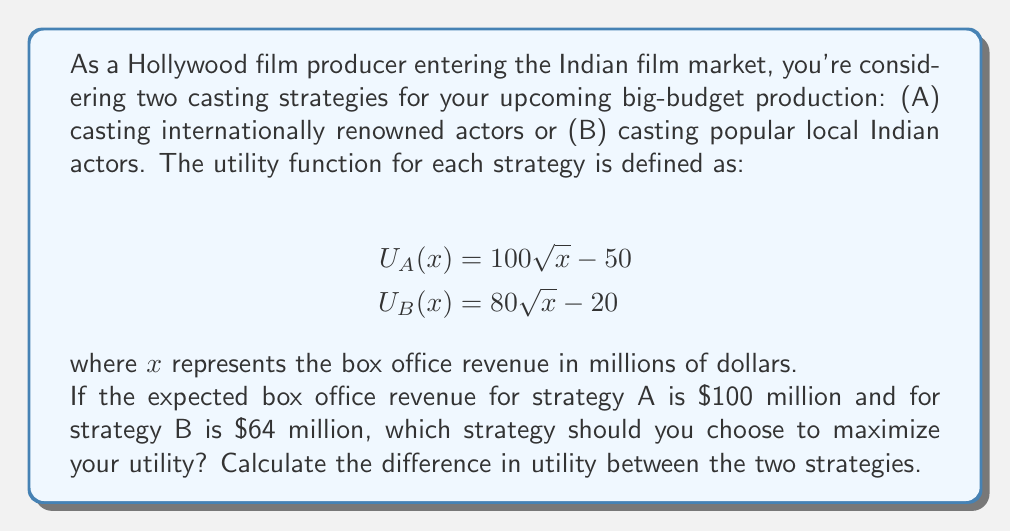Give your solution to this math problem. To solve this problem, we need to calculate the utility for each strategy using the given utility functions and expected box office revenues. Then, we'll compare the results to determine which strategy maximizes utility.

1. Calculate utility for Strategy A (International actors):
   $$U_A(100) = 100\sqrt{100} - 50$$
   $$U_A(100) = 100 \cdot 10 - 50 = 950$$

2. Calculate utility for Strategy B (Local Indian actors):
   $$U_B(64) = 80\sqrt{64} - 20$$
   $$U_B(64) = 80 \cdot 8 - 20 = 620$$

3. Compare the utilities:
   Strategy A yields a higher utility (950) compared to Strategy B (620).

4. Calculate the difference in utility:
   $$\text{Difference} = U_A(100) - U_B(64) = 950 - 620 = 330$$

Therefore, Strategy A (casting internationally renowned actors) should be chosen to maximize utility. The difference in utility between the two strategies is 330 units.
Answer: Choose Strategy A (casting internationally renowned actors). The difference in utility between the two strategies is 330 units. 